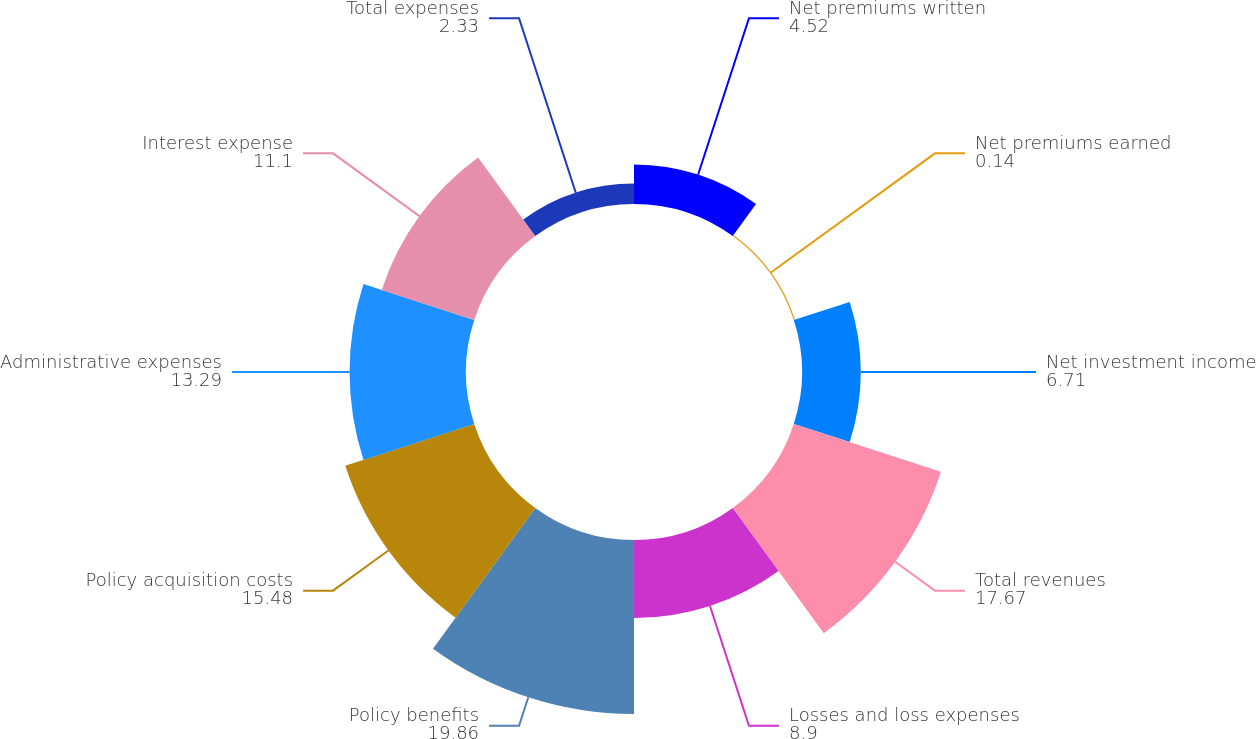Convert chart to OTSL. <chart><loc_0><loc_0><loc_500><loc_500><pie_chart><fcel>Net premiums written<fcel>Net premiums earned<fcel>Net investment income<fcel>Total revenues<fcel>Losses and loss expenses<fcel>Policy benefits<fcel>Policy acquisition costs<fcel>Administrative expenses<fcel>Interest expense<fcel>Total expenses<nl><fcel>4.52%<fcel>0.14%<fcel>6.71%<fcel>17.67%<fcel>8.9%<fcel>19.86%<fcel>15.48%<fcel>13.29%<fcel>11.1%<fcel>2.33%<nl></chart> 